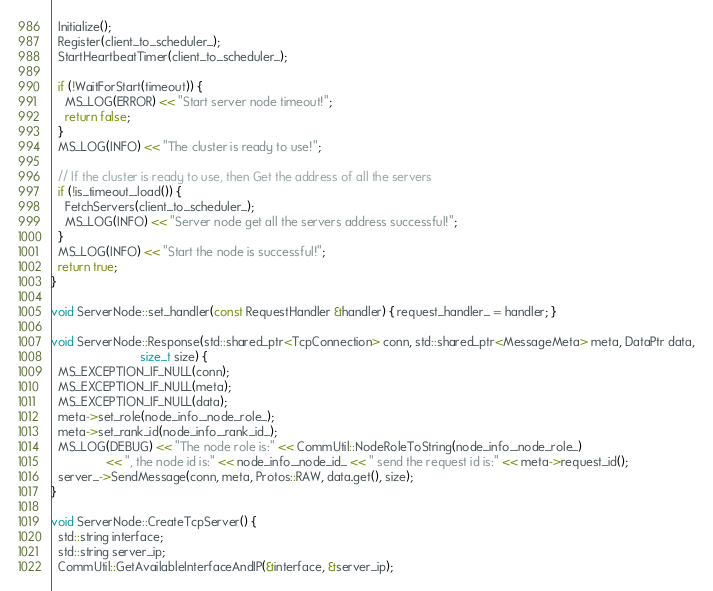<code> <loc_0><loc_0><loc_500><loc_500><_C++_>  Initialize();
  Register(client_to_scheduler_);
  StartHeartbeatTimer(client_to_scheduler_);

  if (!WaitForStart(timeout)) {
    MS_LOG(ERROR) << "Start server node timeout!";
    return false;
  }
  MS_LOG(INFO) << "The cluster is ready to use!";

  // If the cluster is ready to use, then Get the address of all the servers
  if (!is_timeout_.load()) {
    FetchServers(client_to_scheduler_);
    MS_LOG(INFO) << "Server node get all the servers address successful!";
  }
  MS_LOG(INFO) << "Start the node is successful!";
  return true;
}

void ServerNode::set_handler(const RequestHandler &handler) { request_handler_ = handler; }

void ServerNode::Response(std::shared_ptr<TcpConnection> conn, std::shared_ptr<MessageMeta> meta, DataPtr data,
                          size_t size) {
  MS_EXCEPTION_IF_NULL(conn);
  MS_EXCEPTION_IF_NULL(meta);
  MS_EXCEPTION_IF_NULL(data);
  meta->set_role(node_info_.node_role_);
  meta->set_rank_id(node_info_.rank_id_);
  MS_LOG(DEBUG) << "The node role is:" << CommUtil::NodeRoleToString(node_info_.node_role_)
                << ", the node id is:" << node_info_.node_id_ << " send the request id is:" << meta->request_id();
  server_->SendMessage(conn, meta, Protos::RAW, data.get(), size);
}

void ServerNode::CreateTcpServer() {
  std::string interface;
  std::string server_ip;
  CommUtil::GetAvailableInterfaceAndIP(&interface, &server_ip);</code> 